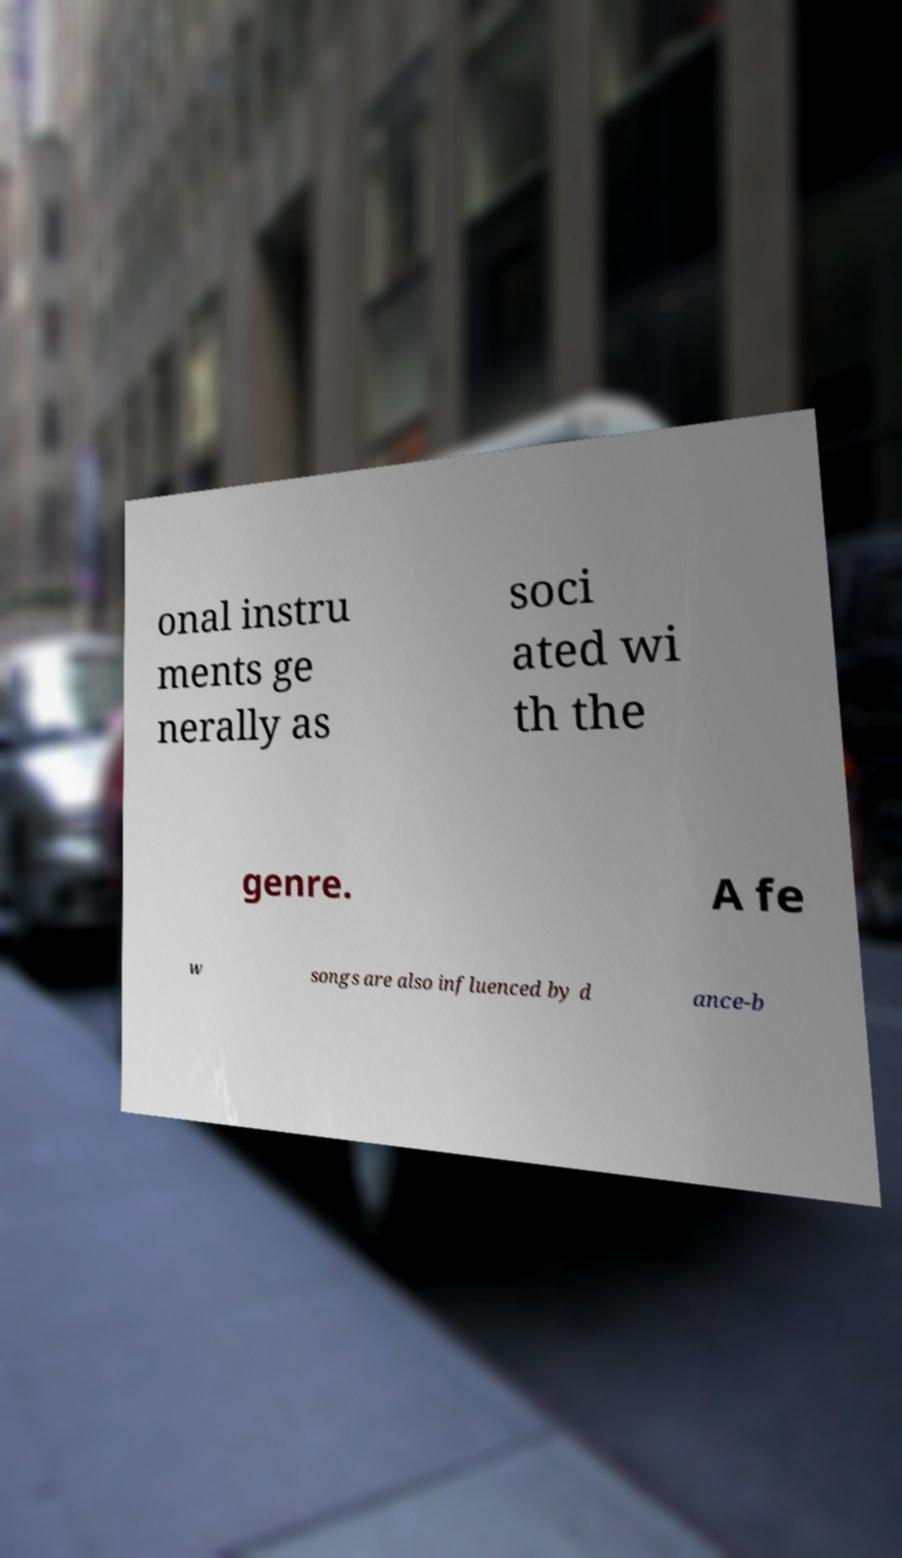Could you assist in decoding the text presented in this image and type it out clearly? onal instru ments ge nerally as soci ated wi th the genre. A fe w songs are also influenced by d ance-b 